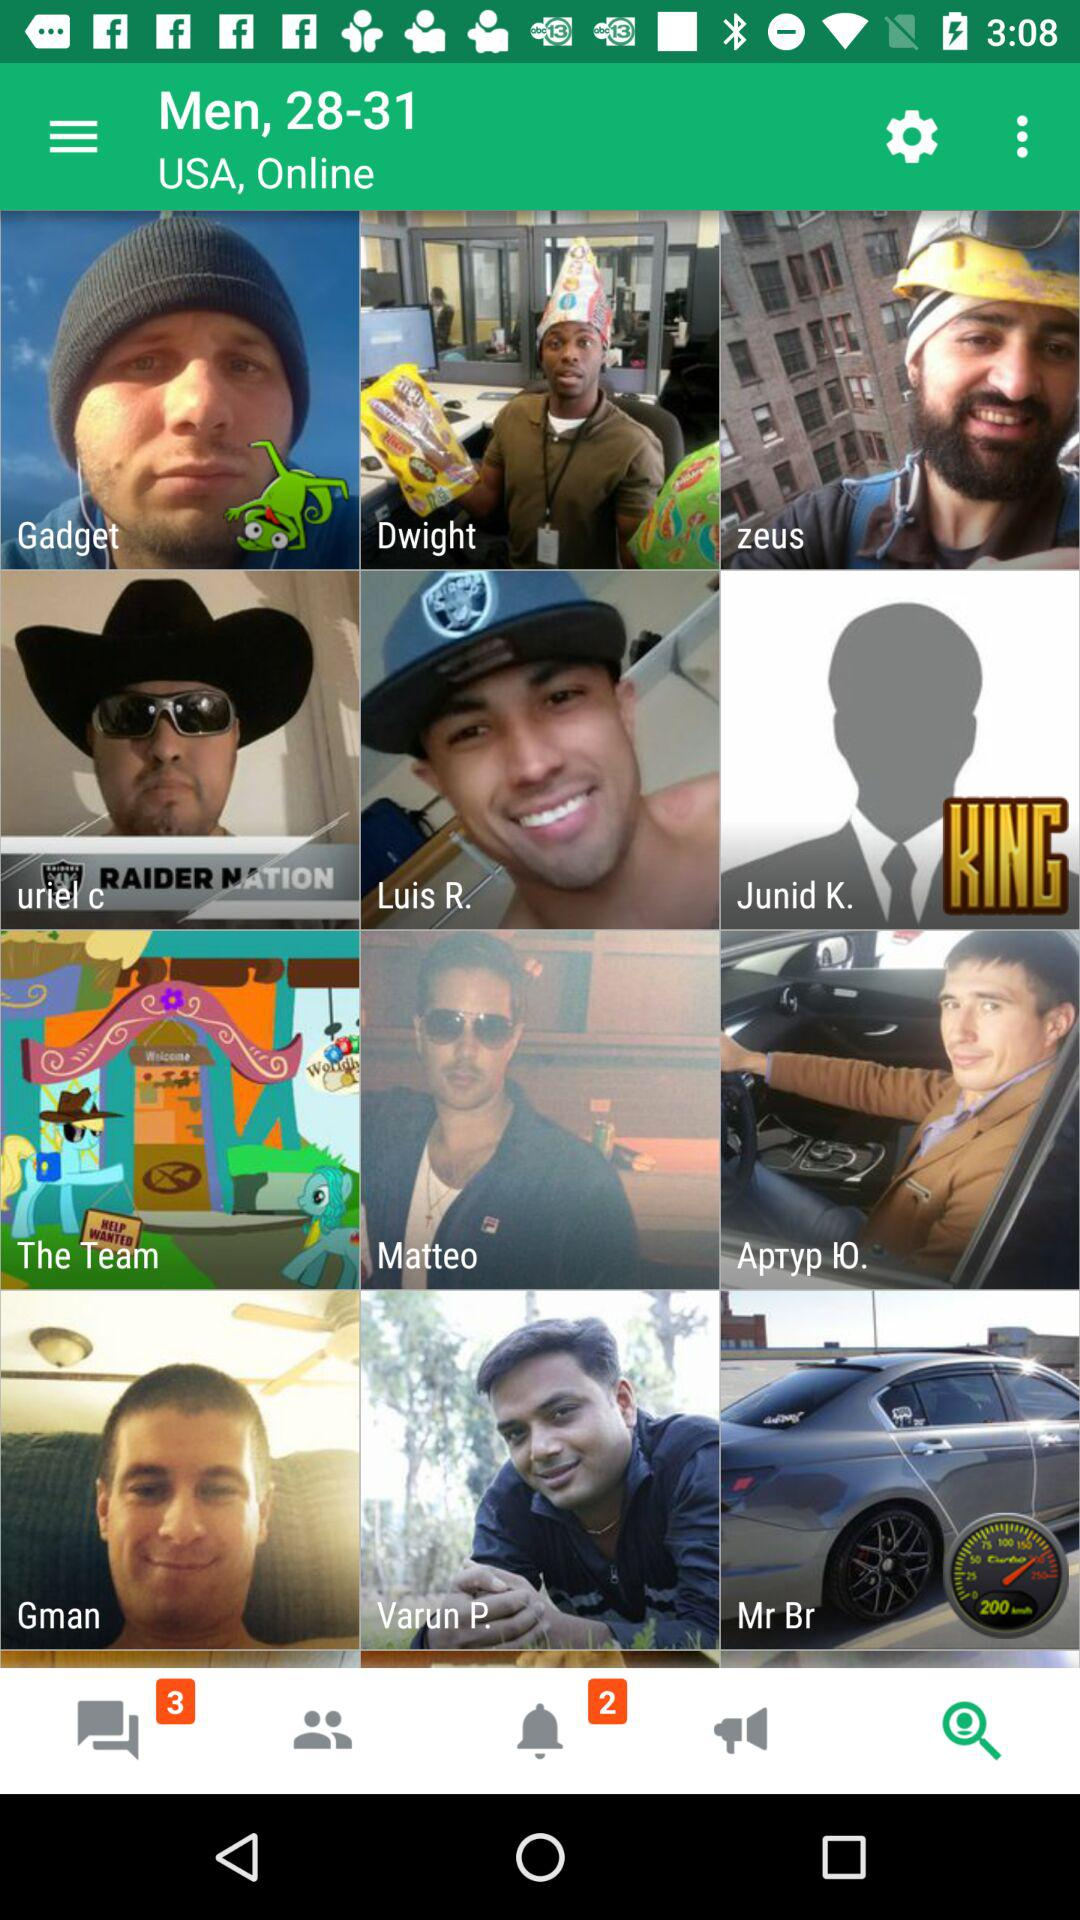What is the selected age range? The selected age range is 28-31. 